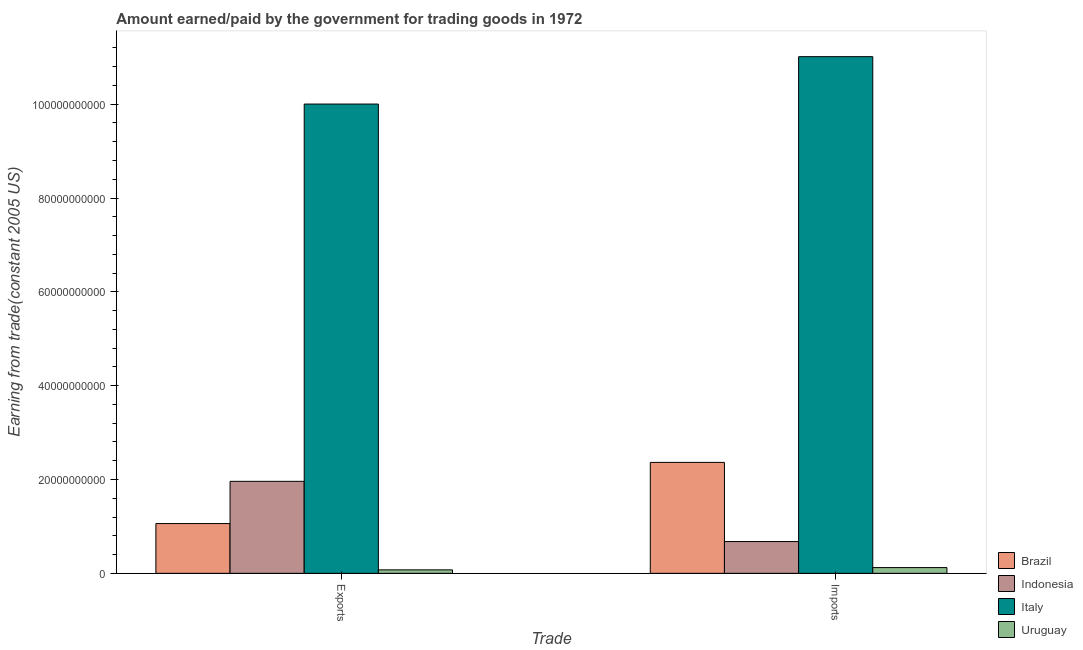How many groups of bars are there?
Ensure brevity in your answer.  2. Are the number of bars per tick equal to the number of legend labels?
Ensure brevity in your answer.  Yes. Are the number of bars on each tick of the X-axis equal?
Your answer should be very brief. Yes. How many bars are there on the 2nd tick from the right?
Offer a terse response. 4. What is the label of the 1st group of bars from the left?
Provide a short and direct response. Exports. What is the amount earned from exports in Italy?
Ensure brevity in your answer.  1.00e+11. Across all countries, what is the maximum amount earned from exports?
Provide a succinct answer. 1.00e+11. Across all countries, what is the minimum amount earned from exports?
Provide a succinct answer. 7.38e+08. In which country was the amount paid for imports maximum?
Your answer should be very brief. Italy. In which country was the amount earned from exports minimum?
Provide a succinct answer. Uruguay. What is the total amount earned from exports in the graph?
Ensure brevity in your answer.  1.31e+11. What is the difference between the amount paid for imports in Italy and that in Brazil?
Provide a succinct answer. 8.65e+1. What is the difference between the amount earned from exports in Uruguay and the amount paid for imports in Indonesia?
Give a very brief answer. -6.04e+09. What is the average amount paid for imports per country?
Offer a very short reply. 3.54e+1. What is the difference between the amount earned from exports and amount paid for imports in Uruguay?
Make the answer very short. -4.86e+08. In how many countries, is the amount earned from exports greater than 16000000000 US$?
Your answer should be compact. 2. What is the ratio of the amount earned from exports in Indonesia to that in Brazil?
Your response must be concise. 1.85. In how many countries, is the amount paid for imports greater than the average amount paid for imports taken over all countries?
Give a very brief answer. 1. What does the 4th bar from the left in Imports represents?
Ensure brevity in your answer.  Uruguay. Are the values on the major ticks of Y-axis written in scientific E-notation?
Your response must be concise. No. Does the graph contain grids?
Your answer should be very brief. No. What is the title of the graph?
Your answer should be very brief. Amount earned/paid by the government for trading goods in 1972. What is the label or title of the X-axis?
Ensure brevity in your answer.  Trade. What is the label or title of the Y-axis?
Ensure brevity in your answer.  Earning from trade(constant 2005 US). What is the Earning from trade(constant 2005 US) of Brazil in Exports?
Give a very brief answer. 1.06e+1. What is the Earning from trade(constant 2005 US) in Indonesia in Exports?
Offer a terse response. 1.96e+1. What is the Earning from trade(constant 2005 US) of Italy in Exports?
Ensure brevity in your answer.  1.00e+11. What is the Earning from trade(constant 2005 US) of Uruguay in Exports?
Ensure brevity in your answer.  7.38e+08. What is the Earning from trade(constant 2005 US) of Brazil in Imports?
Offer a very short reply. 2.36e+1. What is the Earning from trade(constant 2005 US) of Indonesia in Imports?
Ensure brevity in your answer.  6.77e+09. What is the Earning from trade(constant 2005 US) of Italy in Imports?
Provide a short and direct response. 1.10e+11. What is the Earning from trade(constant 2005 US) in Uruguay in Imports?
Provide a short and direct response. 1.22e+09. Across all Trade, what is the maximum Earning from trade(constant 2005 US) in Brazil?
Provide a succinct answer. 2.36e+1. Across all Trade, what is the maximum Earning from trade(constant 2005 US) in Indonesia?
Your answer should be compact. 1.96e+1. Across all Trade, what is the maximum Earning from trade(constant 2005 US) in Italy?
Provide a succinct answer. 1.10e+11. Across all Trade, what is the maximum Earning from trade(constant 2005 US) of Uruguay?
Ensure brevity in your answer.  1.22e+09. Across all Trade, what is the minimum Earning from trade(constant 2005 US) of Brazil?
Keep it short and to the point. 1.06e+1. Across all Trade, what is the minimum Earning from trade(constant 2005 US) of Indonesia?
Your answer should be compact. 6.77e+09. Across all Trade, what is the minimum Earning from trade(constant 2005 US) in Italy?
Offer a terse response. 1.00e+11. Across all Trade, what is the minimum Earning from trade(constant 2005 US) in Uruguay?
Your answer should be compact. 7.38e+08. What is the total Earning from trade(constant 2005 US) in Brazil in the graph?
Provide a succinct answer. 3.43e+1. What is the total Earning from trade(constant 2005 US) in Indonesia in the graph?
Keep it short and to the point. 2.64e+1. What is the total Earning from trade(constant 2005 US) of Italy in the graph?
Give a very brief answer. 2.10e+11. What is the total Earning from trade(constant 2005 US) of Uruguay in the graph?
Ensure brevity in your answer.  1.96e+09. What is the difference between the Earning from trade(constant 2005 US) of Brazil in Exports and that in Imports?
Make the answer very short. -1.30e+1. What is the difference between the Earning from trade(constant 2005 US) in Indonesia in Exports and that in Imports?
Give a very brief answer. 1.28e+1. What is the difference between the Earning from trade(constant 2005 US) in Italy in Exports and that in Imports?
Provide a short and direct response. -1.01e+1. What is the difference between the Earning from trade(constant 2005 US) of Uruguay in Exports and that in Imports?
Offer a very short reply. -4.86e+08. What is the difference between the Earning from trade(constant 2005 US) of Brazil in Exports and the Earning from trade(constant 2005 US) of Indonesia in Imports?
Make the answer very short. 3.83e+09. What is the difference between the Earning from trade(constant 2005 US) in Brazil in Exports and the Earning from trade(constant 2005 US) in Italy in Imports?
Provide a short and direct response. -9.95e+1. What is the difference between the Earning from trade(constant 2005 US) of Brazil in Exports and the Earning from trade(constant 2005 US) of Uruguay in Imports?
Ensure brevity in your answer.  9.38e+09. What is the difference between the Earning from trade(constant 2005 US) of Indonesia in Exports and the Earning from trade(constant 2005 US) of Italy in Imports?
Your answer should be compact. -9.05e+1. What is the difference between the Earning from trade(constant 2005 US) in Indonesia in Exports and the Earning from trade(constant 2005 US) in Uruguay in Imports?
Your answer should be very brief. 1.84e+1. What is the difference between the Earning from trade(constant 2005 US) in Italy in Exports and the Earning from trade(constant 2005 US) in Uruguay in Imports?
Make the answer very short. 9.88e+1. What is the average Earning from trade(constant 2005 US) of Brazil per Trade?
Give a very brief answer. 1.71e+1. What is the average Earning from trade(constant 2005 US) of Indonesia per Trade?
Your answer should be very brief. 1.32e+1. What is the average Earning from trade(constant 2005 US) of Italy per Trade?
Your answer should be compact. 1.05e+11. What is the average Earning from trade(constant 2005 US) of Uruguay per Trade?
Make the answer very short. 9.82e+08. What is the difference between the Earning from trade(constant 2005 US) of Brazil and Earning from trade(constant 2005 US) of Indonesia in Exports?
Offer a terse response. -9.00e+09. What is the difference between the Earning from trade(constant 2005 US) in Brazil and Earning from trade(constant 2005 US) in Italy in Exports?
Offer a terse response. -8.94e+1. What is the difference between the Earning from trade(constant 2005 US) of Brazil and Earning from trade(constant 2005 US) of Uruguay in Exports?
Offer a terse response. 9.87e+09. What is the difference between the Earning from trade(constant 2005 US) in Indonesia and Earning from trade(constant 2005 US) in Italy in Exports?
Provide a short and direct response. -8.04e+1. What is the difference between the Earning from trade(constant 2005 US) of Indonesia and Earning from trade(constant 2005 US) of Uruguay in Exports?
Offer a terse response. 1.89e+1. What is the difference between the Earning from trade(constant 2005 US) of Italy and Earning from trade(constant 2005 US) of Uruguay in Exports?
Provide a short and direct response. 9.93e+1. What is the difference between the Earning from trade(constant 2005 US) of Brazil and Earning from trade(constant 2005 US) of Indonesia in Imports?
Your response must be concise. 1.69e+1. What is the difference between the Earning from trade(constant 2005 US) of Brazil and Earning from trade(constant 2005 US) of Italy in Imports?
Ensure brevity in your answer.  -8.65e+1. What is the difference between the Earning from trade(constant 2005 US) of Brazil and Earning from trade(constant 2005 US) of Uruguay in Imports?
Offer a very short reply. 2.24e+1. What is the difference between the Earning from trade(constant 2005 US) of Indonesia and Earning from trade(constant 2005 US) of Italy in Imports?
Give a very brief answer. -1.03e+11. What is the difference between the Earning from trade(constant 2005 US) in Indonesia and Earning from trade(constant 2005 US) in Uruguay in Imports?
Give a very brief answer. 5.55e+09. What is the difference between the Earning from trade(constant 2005 US) in Italy and Earning from trade(constant 2005 US) in Uruguay in Imports?
Give a very brief answer. 1.09e+11. What is the ratio of the Earning from trade(constant 2005 US) of Brazil in Exports to that in Imports?
Provide a succinct answer. 0.45. What is the ratio of the Earning from trade(constant 2005 US) in Indonesia in Exports to that in Imports?
Your answer should be compact. 2.89. What is the ratio of the Earning from trade(constant 2005 US) of Italy in Exports to that in Imports?
Keep it short and to the point. 0.91. What is the ratio of the Earning from trade(constant 2005 US) of Uruguay in Exports to that in Imports?
Provide a short and direct response. 0.6. What is the difference between the highest and the second highest Earning from trade(constant 2005 US) of Brazil?
Provide a succinct answer. 1.30e+1. What is the difference between the highest and the second highest Earning from trade(constant 2005 US) of Indonesia?
Offer a terse response. 1.28e+1. What is the difference between the highest and the second highest Earning from trade(constant 2005 US) of Italy?
Provide a short and direct response. 1.01e+1. What is the difference between the highest and the second highest Earning from trade(constant 2005 US) in Uruguay?
Your response must be concise. 4.86e+08. What is the difference between the highest and the lowest Earning from trade(constant 2005 US) of Brazil?
Provide a short and direct response. 1.30e+1. What is the difference between the highest and the lowest Earning from trade(constant 2005 US) of Indonesia?
Keep it short and to the point. 1.28e+1. What is the difference between the highest and the lowest Earning from trade(constant 2005 US) in Italy?
Provide a succinct answer. 1.01e+1. What is the difference between the highest and the lowest Earning from trade(constant 2005 US) in Uruguay?
Give a very brief answer. 4.86e+08. 